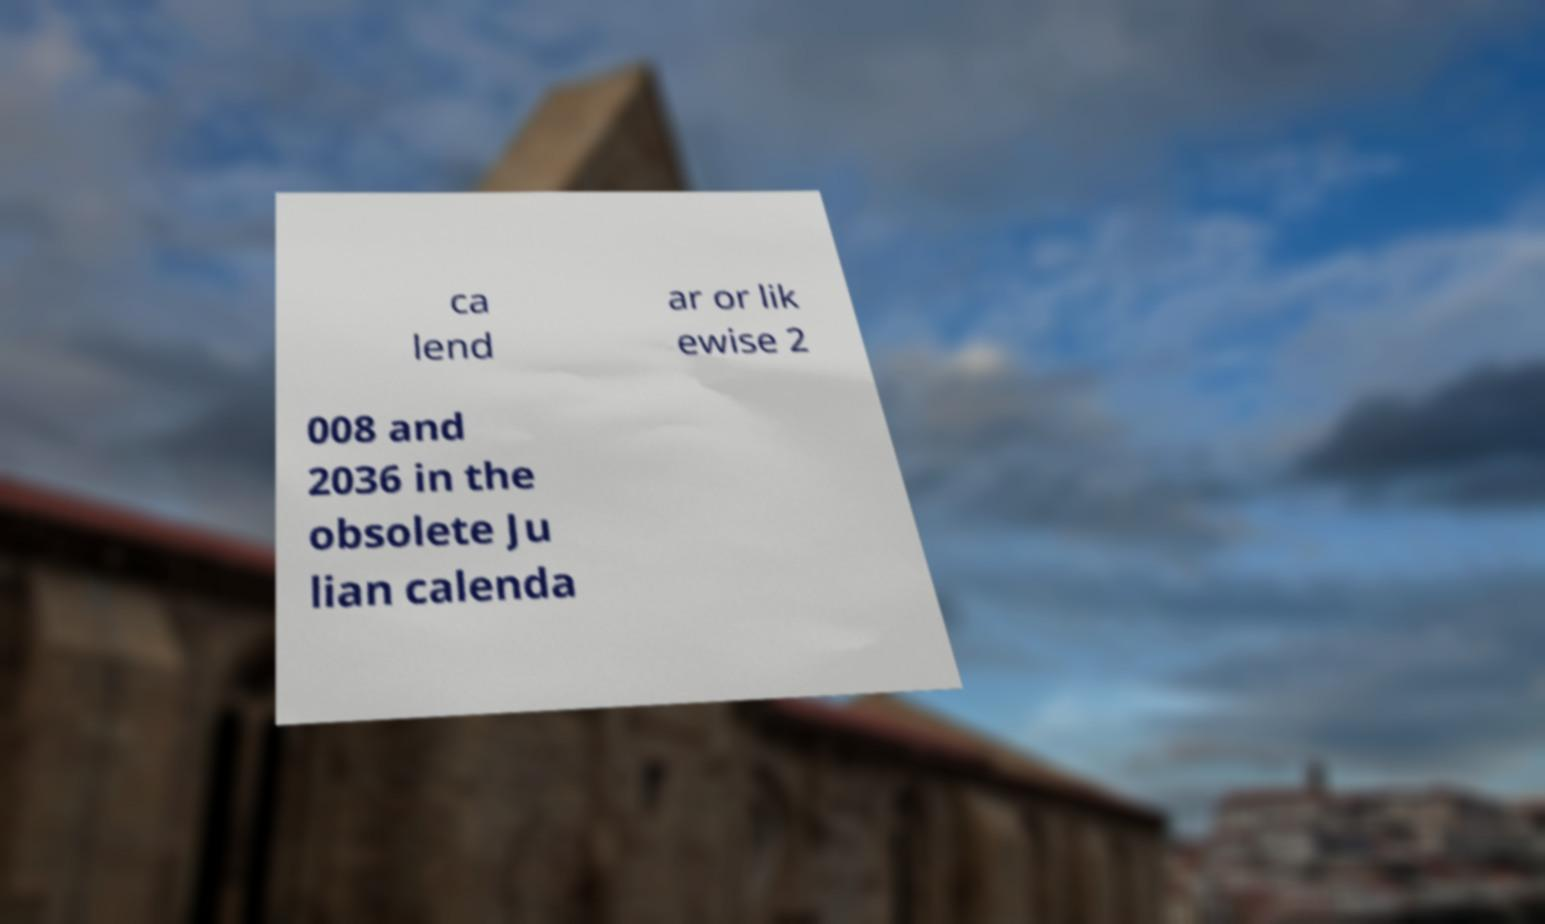Can you read and provide the text displayed in the image?This photo seems to have some interesting text. Can you extract and type it out for me? ca lend ar or lik ewise 2 008 and 2036 in the obsolete Ju lian calenda 